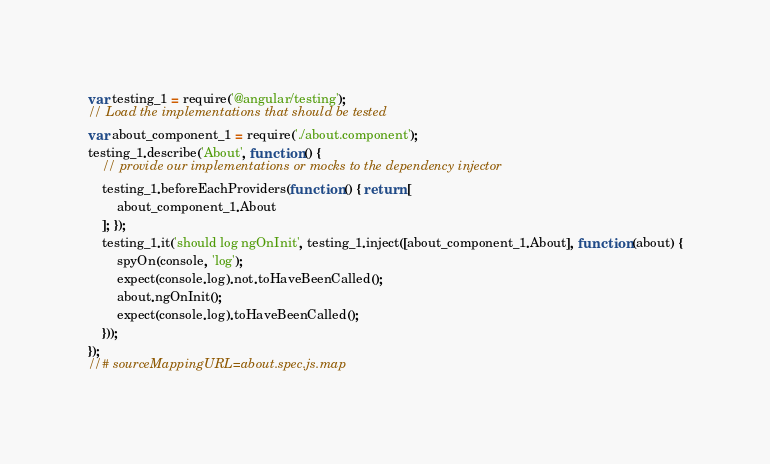<code> <loc_0><loc_0><loc_500><loc_500><_JavaScript_>var testing_1 = require('@angular/testing');
// Load the implementations that should be tested
var about_component_1 = require('./about.component');
testing_1.describe('About', function () {
    // provide our implementations or mocks to the dependency injector
    testing_1.beforeEachProviders(function () { return [
        about_component_1.About
    ]; });
    testing_1.it('should log ngOnInit', testing_1.inject([about_component_1.About], function (about) {
        spyOn(console, 'log');
        expect(console.log).not.toHaveBeenCalled();
        about.ngOnInit();
        expect(console.log).toHaveBeenCalled();
    }));
});
//# sourceMappingURL=about.spec.js.map</code> 